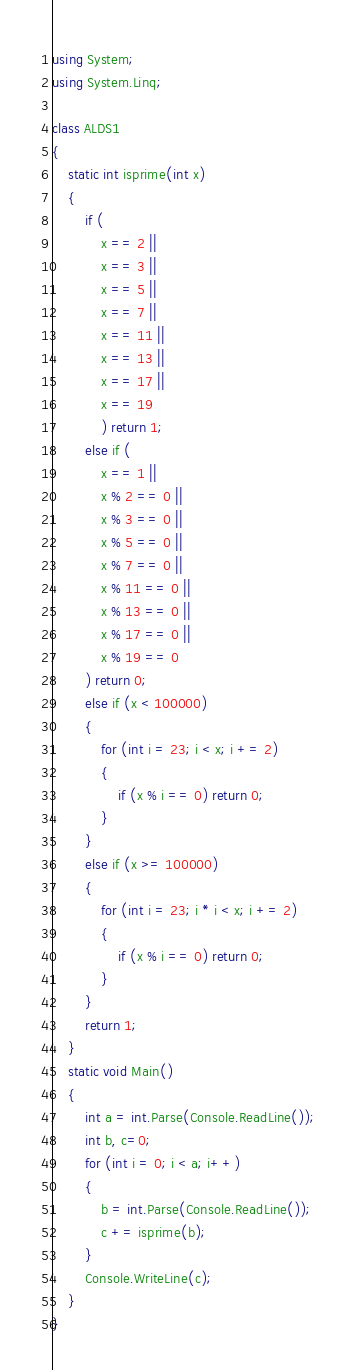<code> <loc_0><loc_0><loc_500><loc_500><_C#_>using System;
using System.Linq;

class ALDS1
{
    static int isprime(int x)
    {
        if (
            x == 2 ||
            x == 3 ||
            x == 5 ||
            x == 7 ||
            x == 11 ||
            x == 13 ||
            x == 17 ||
            x == 19
            ) return 1;
        else if (
            x == 1 ||
            x % 2 == 0 ||
            x % 3 == 0 ||
            x % 5 == 0 ||
            x % 7 == 0 ||
            x % 11 == 0 ||
            x % 13 == 0 ||
            x % 17 == 0 ||
            x % 19 == 0
        ) return 0;
        else if (x < 100000)
        {
            for (int i = 23; i < x; i += 2)
            {
                if (x % i == 0) return 0;
            }
        }
        else if (x >= 100000)
        {
            for (int i = 23; i * i < x; i += 2)
            {
                if (x % i == 0) return 0;
            }
        }
        return 1;
    }
    static void Main()
    {
        int a = int.Parse(Console.ReadLine());
        int b, c=0;
        for (int i = 0; i < a; i++)
        {
            b = int.Parse(Console.ReadLine());
            c += isprime(b);
        }
        Console.WriteLine(c);
    }
}</code> 